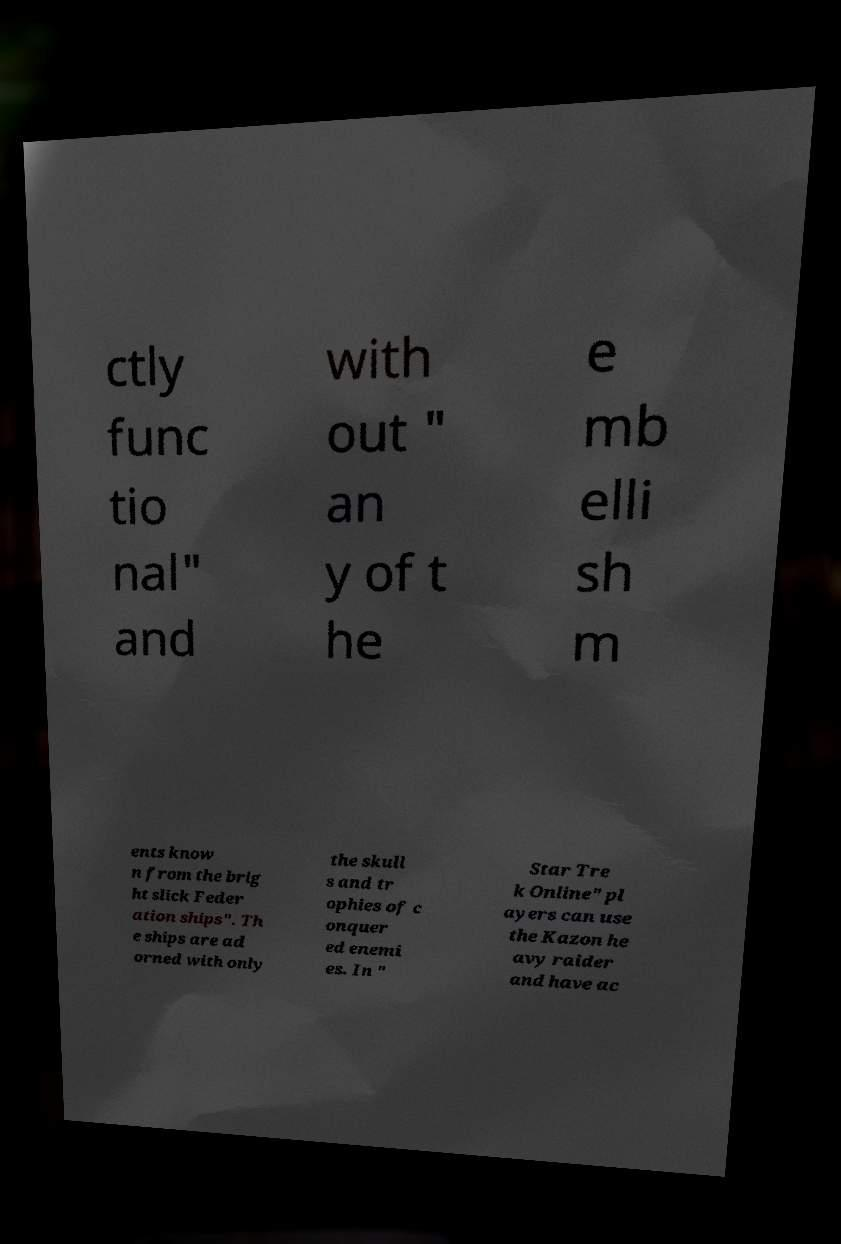Please identify and transcribe the text found in this image. ctly func tio nal" and with out " an y of t he e mb elli sh m ents know n from the brig ht slick Feder ation ships". Th e ships are ad orned with only the skull s and tr ophies of c onquer ed enemi es. In " Star Tre k Online" pl ayers can use the Kazon he avy raider and have ac 